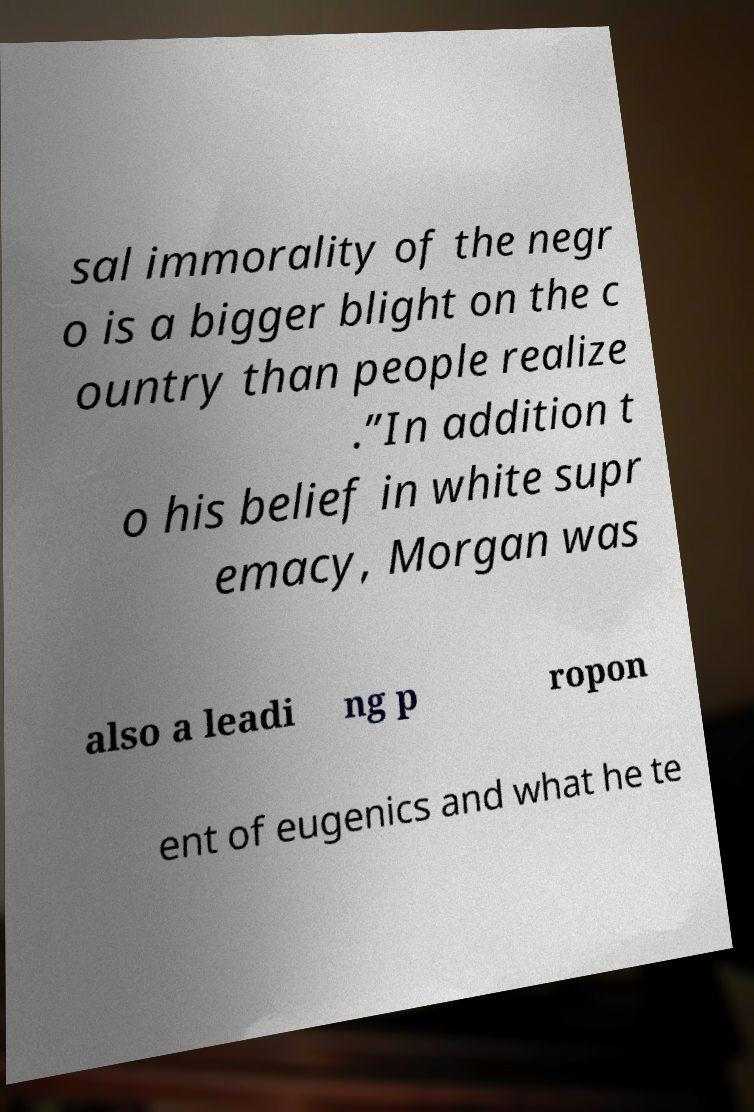For documentation purposes, I need the text within this image transcribed. Could you provide that? sal immorality of the negr o is a bigger blight on the c ountry than people realize .”In addition t o his belief in white supr emacy, Morgan was also a leadi ng p ropon ent of eugenics and what he te 